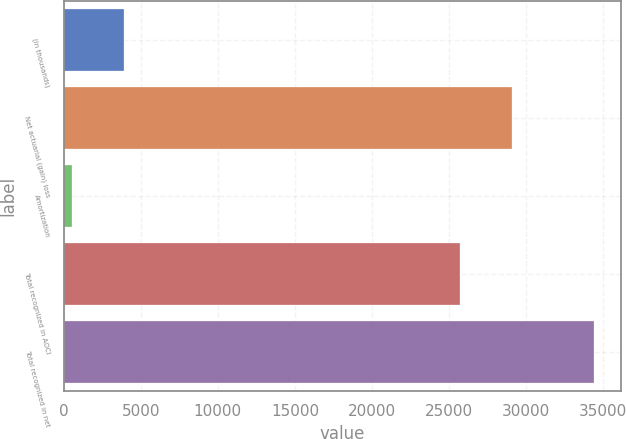Convert chart. <chart><loc_0><loc_0><loc_500><loc_500><bar_chart><fcel>(in thousands)<fcel>Net actuarial (gain) loss<fcel>Amortization<fcel>Total recognized in AOCI<fcel>Total recognized in net<nl><fcel>3924<fcel>29095<fcel>536<fcel>25707<fcel>34416<nl></chart> 